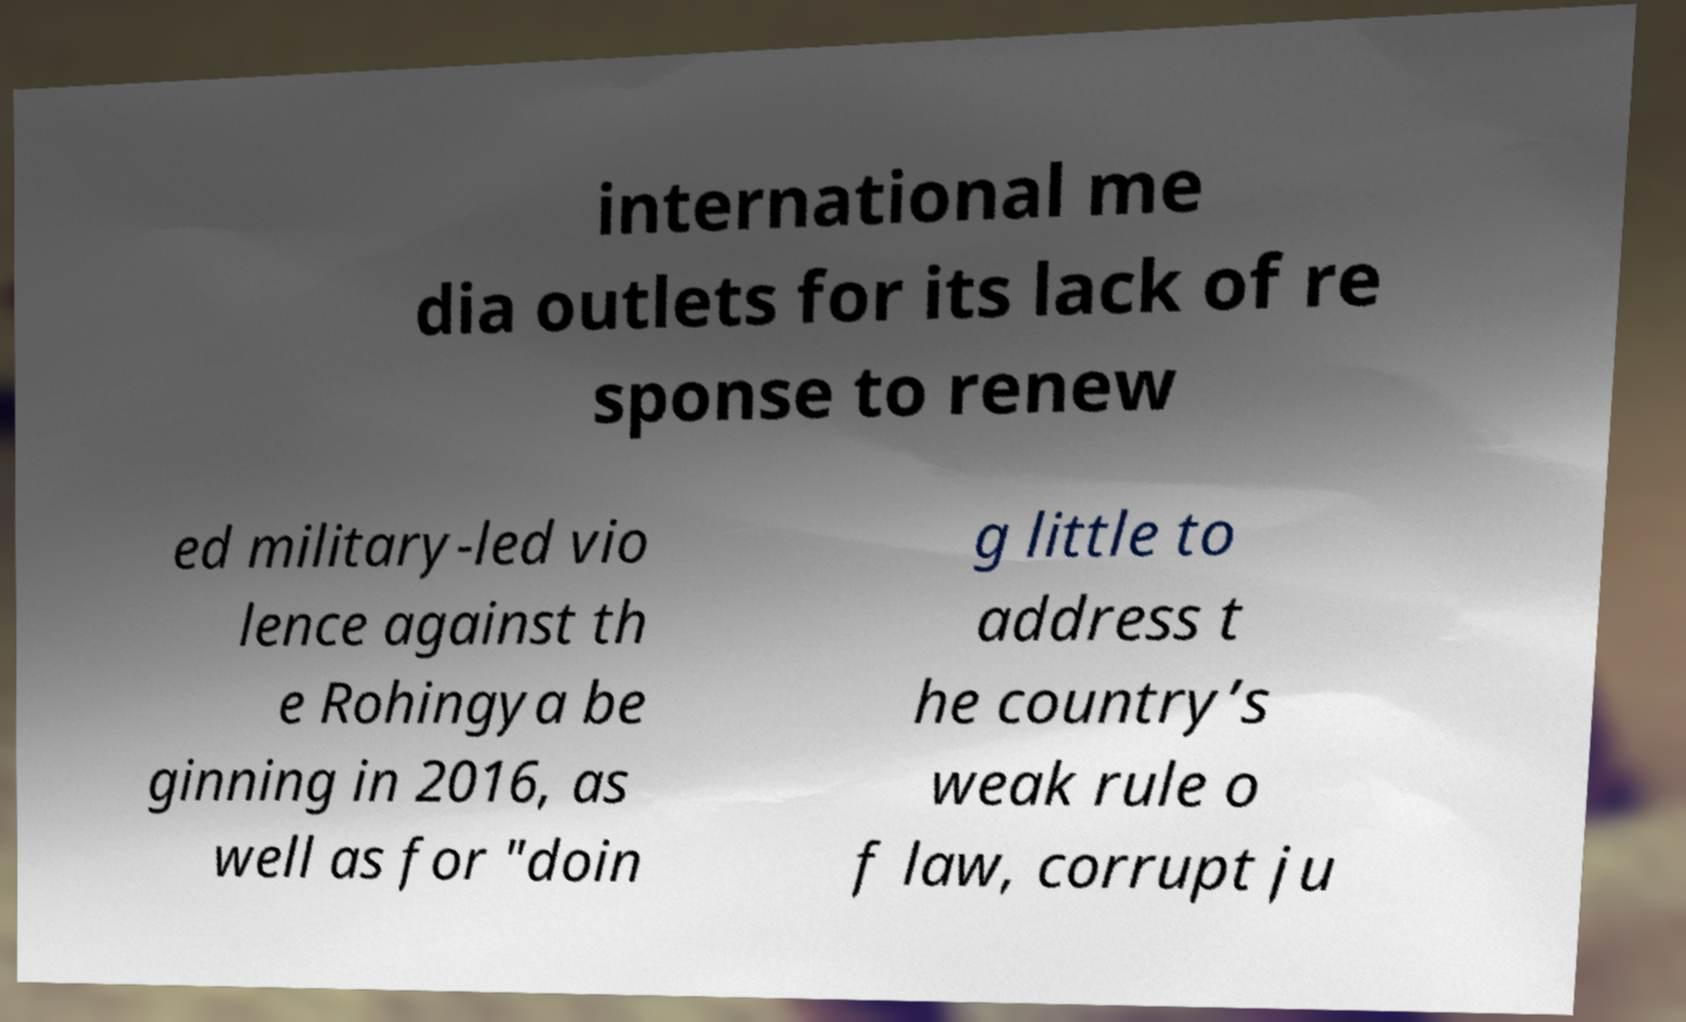Could you assist in decoding the text presented in this image and type it out clearly? international me dia outlets for its lack of re sponse to renew ed military-led vio lence against th e Rohingya be ginning in 2016, as well as for "doin g little to address t he country’s weak rule o f law, corrupt ju 